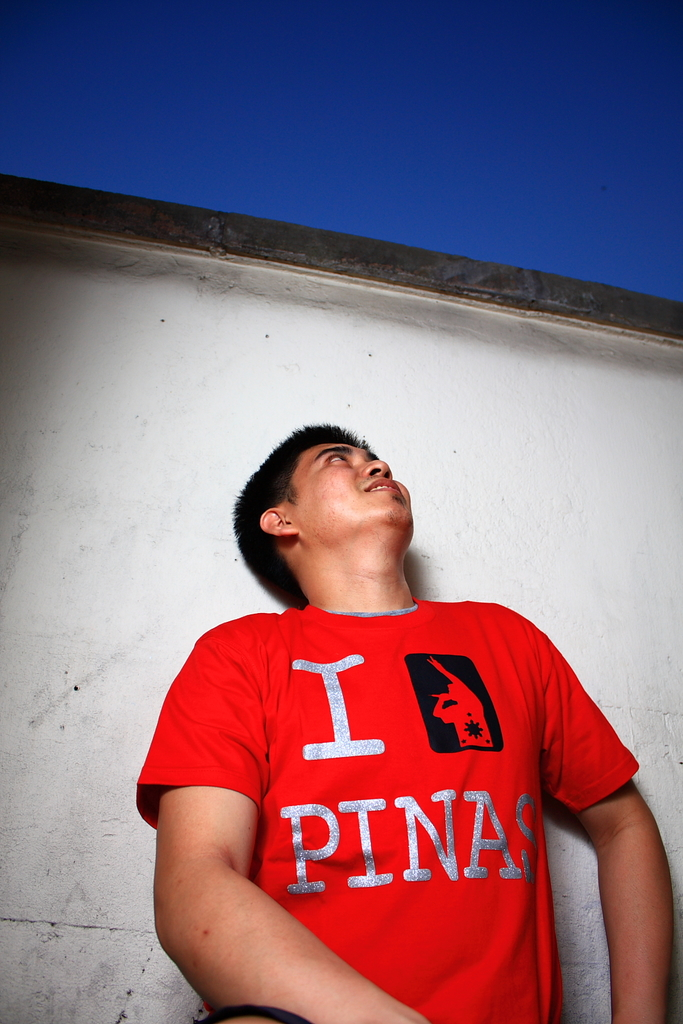Provide a one-sentence caption for the provided image.
Reference OCR token: I, PINA A man wears a red "I Love Pinas" shirt. 